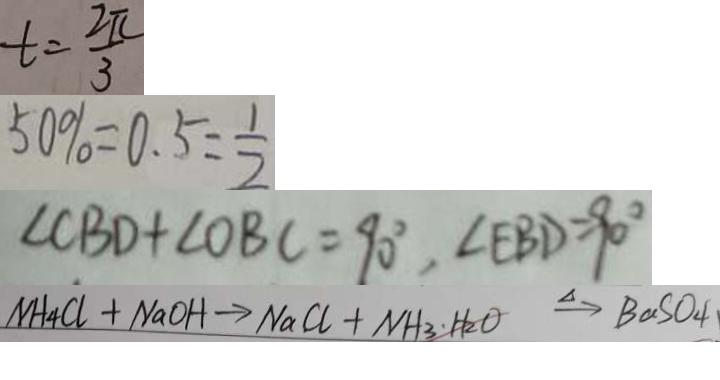Convert formula to latex. <formula><loc_0><loc_0><loc_500><loc_500>t = \frac { 2 \pi } { 3 } 
 5 0 \% = 0 . 5 = \frac { 1 } { 2 } 
 \angle C B D + \angle O B C = 9 0 ^ { \circ } , \angle E B D = 9 0 ^ { \circ } 
 N H _ { 4 } C l + N a O H \rightarrow N a C l + N H _ { 3 } \cdot \xrightarrow { \Delta } B a S O _ { 4 }</formula> 